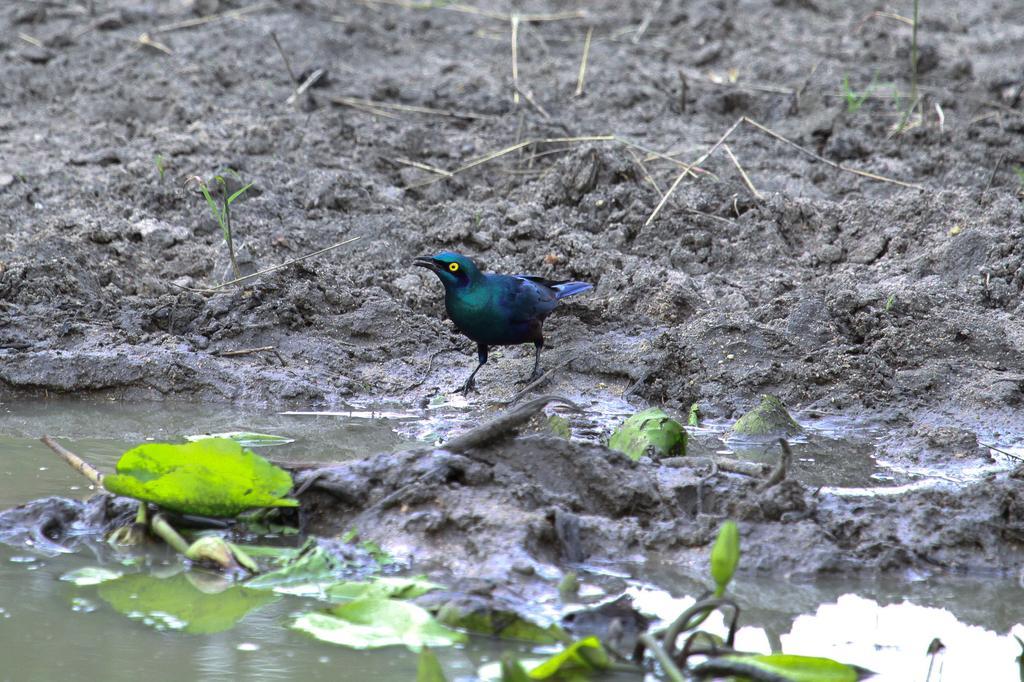Describe this image in one or two sentences. In this image there is a bird represent on the mud. We can also see water and leaves in this image. 